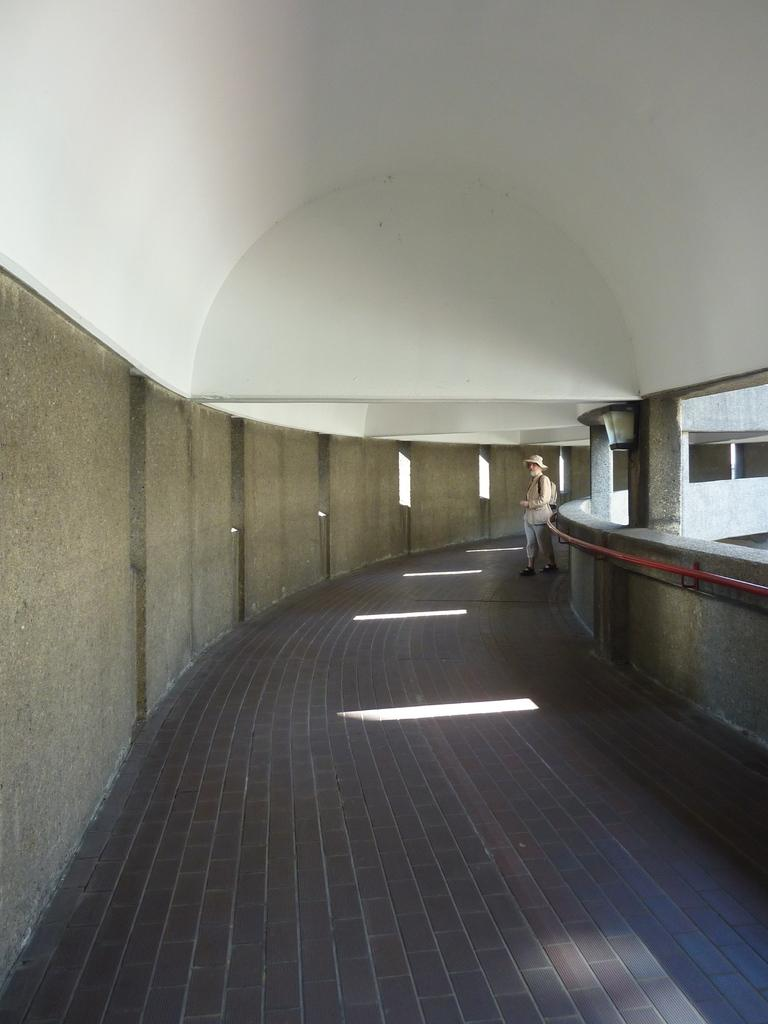What is the person in the image doing? There is a person standing inside a building. What objects can be seen inside the building? There is an iron rod and pillars visible inside the building. What type of pet can be seen playing with the iron rod in the image? There is no pet present in the image, and therefore no such activity can be observed. What type of tramp is visible in the building in the image? There is no tramp present in the image; it features a person standing inside a building with an iron rod and pillars. 